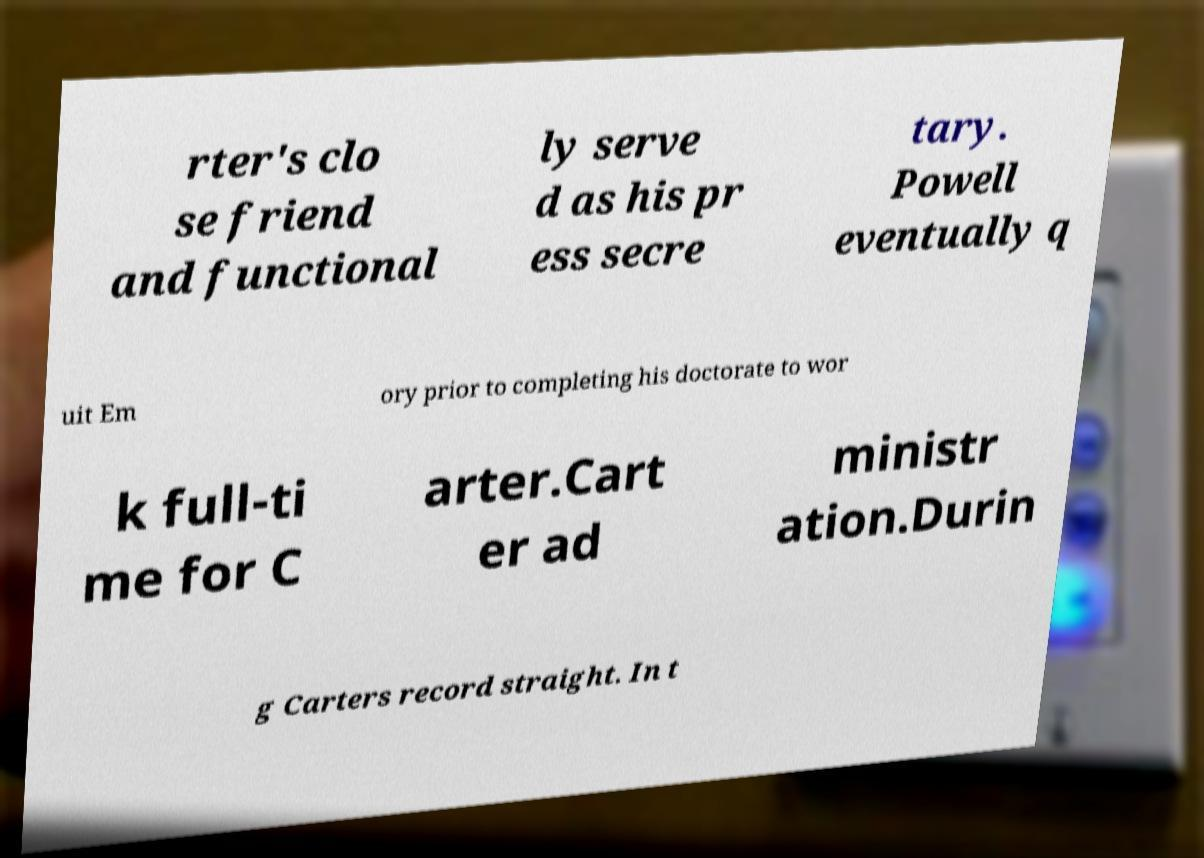There's text embedded in this image that I need extracted. Can you transcribe it verbatim? rter's clo se friend and functional ly serve d as his pr ess secre tary. Powell eventually q uit Em ory prior to completing his doctorate to wor k full-ti me for C arter.Cart er ad ministr ation.Durin g Carters record straight. In t 